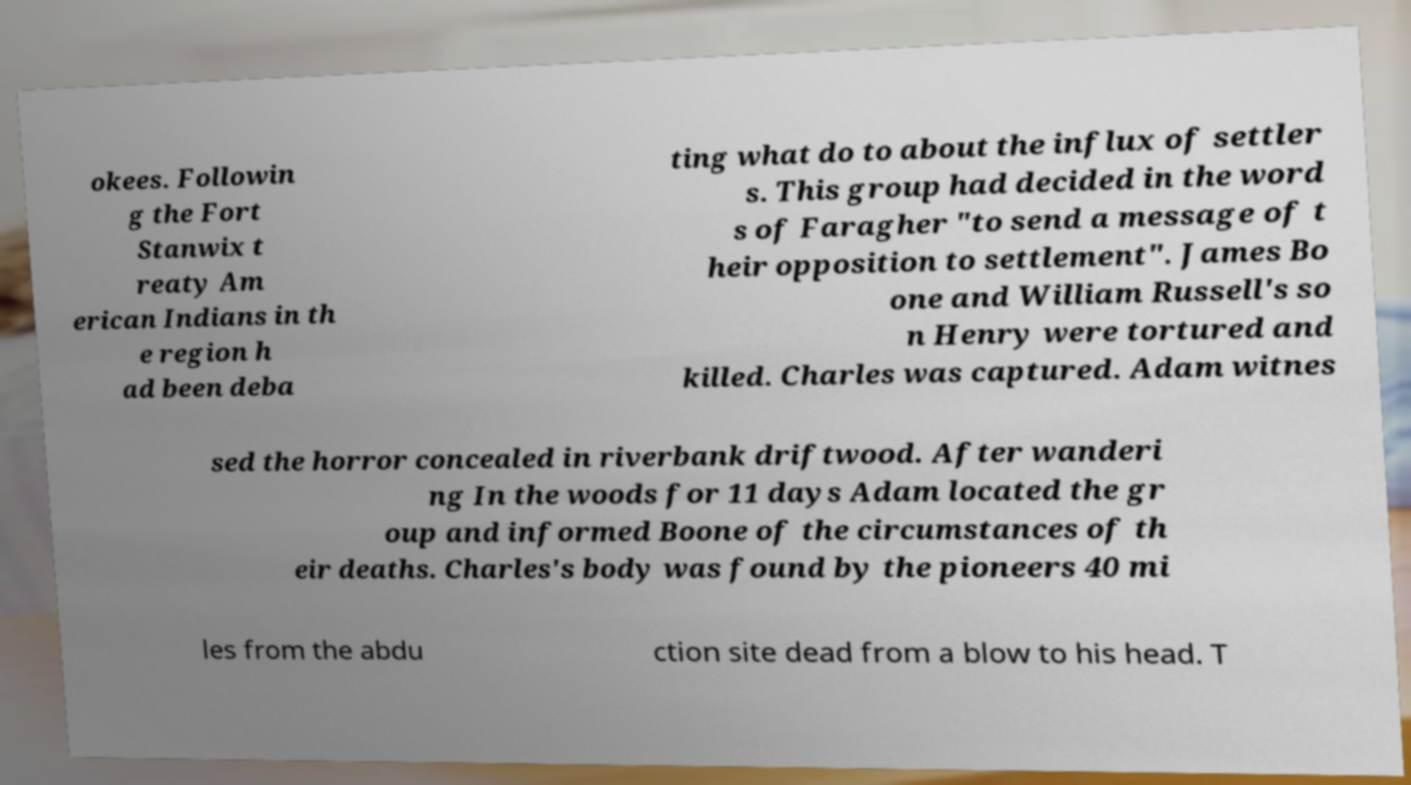Could you extract and type out the text from this image? okees. Followin g the Fort Stanwix t reaty Am erican Indians in th e region h ad been deba ting what do to about the influx of settler s. This group had decided in the word s of Faragher "to send a message of t heir opposition to settlement". James Bo one and William Russell's so n Henry were tortured and killed. Charles was captured. Adam witnes sed the horror concealed in riverbank driftwood. After wanderi ng In the woods for 11 days Adam located the gr oup and informed Boone of the circumstances of th eir deaths. Charles's body was found by the pioneers 40 mi les from the abdu ction site dead from a blow to his head. T 